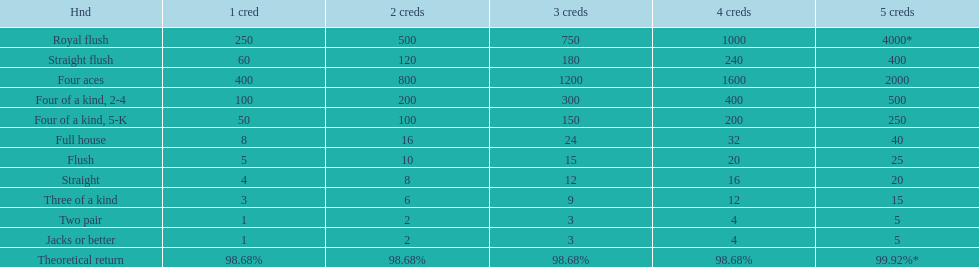Which hand is the top hand in the card game super aces? Royal flush. 